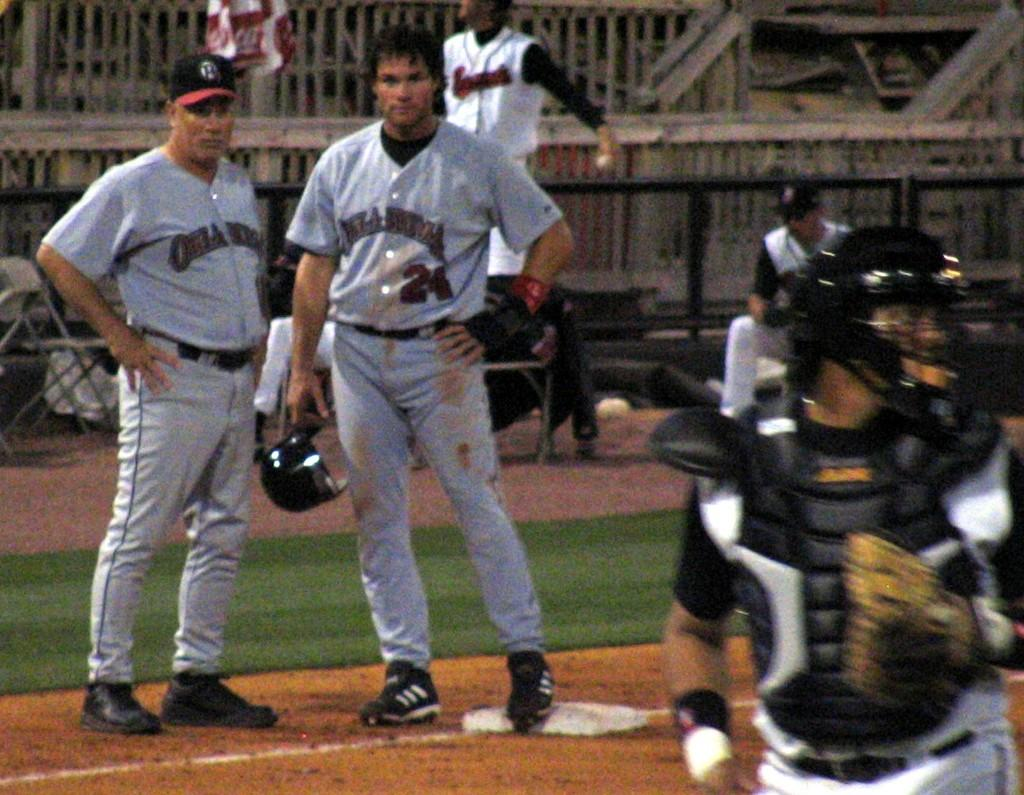<image>
Present a compact description of the photo's key features. Two baseball players standing side by side with one wearing the number 24. 